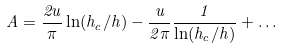<formula> <loc_0><loc_0><loc_500><loc_500>A = \frac { 2 u } { \pi } \ln ( { h _ { c } } / { h } ) - \frac { u } { 2 \pi } \frac { 1 } { \ln ( h _ { c } / h ) } + \dots</formula> 